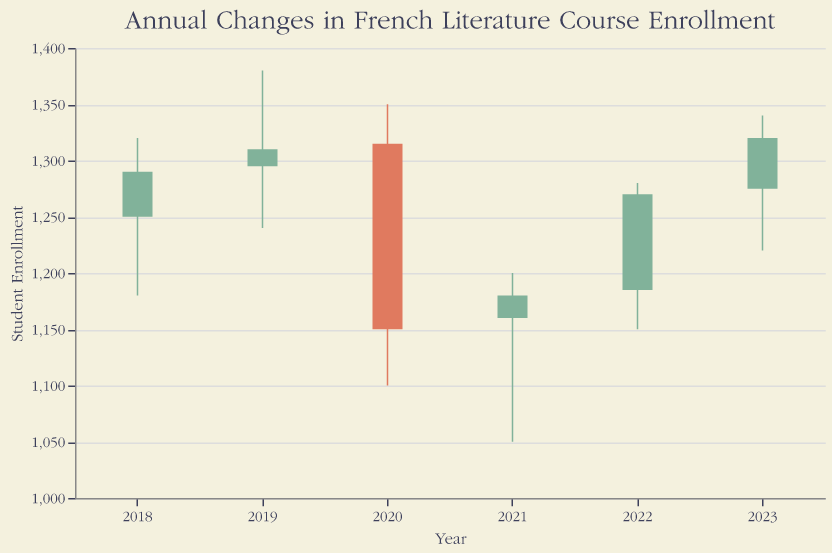What is the title of the chart? The title of the chart is usually displayed at the top and it provides a brief description of what the chart is about. In this case, it mentions "Annual Changes in French Literature Course Enrollment".
Answer: Annual Changes in French Literature Course Enrollment How many data points (years) are displayed in the chart? To find the number of data points, count the number of bars or entries in the chart. Each bar represents a year, and they are labeled on the x-axis.
Answer: 6 What was the highest student enrollment recorded in 2020? To answer this, look at the data point for 2020 and identify the highest value between the opening, highest, lowest, and closing numbers. The highest value is represented by the top end of the vertical line.
Answer: 1350 Which year experienced the lowest closing student enrollment? To find this, scan through the closing values for each year and identify the smallest number. The closing number for each year is the end of each bar.
Answer: 2020 In which years did the closing student enrollment exceed the opening student enrollment? To determine this, look for years where the closing value (end of the bar) is greater than the opening value (start of the bar). These years typically have bars colored differently (refer to the color condition for bars).
Answer: 2018, 2019, 2022, 2023 What was the range of student enrollment values in 2021? The range is calculated by subtracting the lowest value from the highest value. Refer to the lowest and highest values for 2021.
Answer: 150 What is the average closing student enrollment for the years presented? To find the average, sum up all the closing values and divide by the number of years. Add up the closing values: 1290 + 1310 + 1150 + 1180 + 1270 + 1320, then divide by 6.
Answer: 1253.33 Which year had the most stable (least range) student enrollment? Stability in enrollment can be judged by the smallest range between the highest and lowest enrollments. Check the difference between the highest and lowest for each year and determine the smallest one.
Answer: 2021 In which year did the enrollment decrease the most when comparing the opening and closing values? To determine this, calculate the difference between the opening and closing values for each year and identify the most significant decrease.
Answer: 2020 